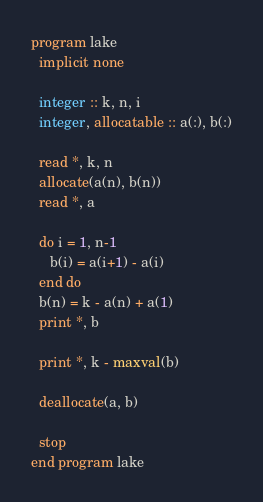<code> <loc_0><loc_0><loc_500><loc_500><_FORTRAN_>program lake
  implicit none

  integer :: k, n, i
  integer, allocatable :: a(:), b(:)

  read *, k, n
  allocate(a(n), b(n))
  read *, a

  do i = 1, n-1
     b(i) = a(i+1) - a(i)
  end do
  b(n) = k - a(n) + a(1)
  print *, b

  print *, k - maxval(b)

  deallocate(a, b)

  stop
end program lake
</code> 